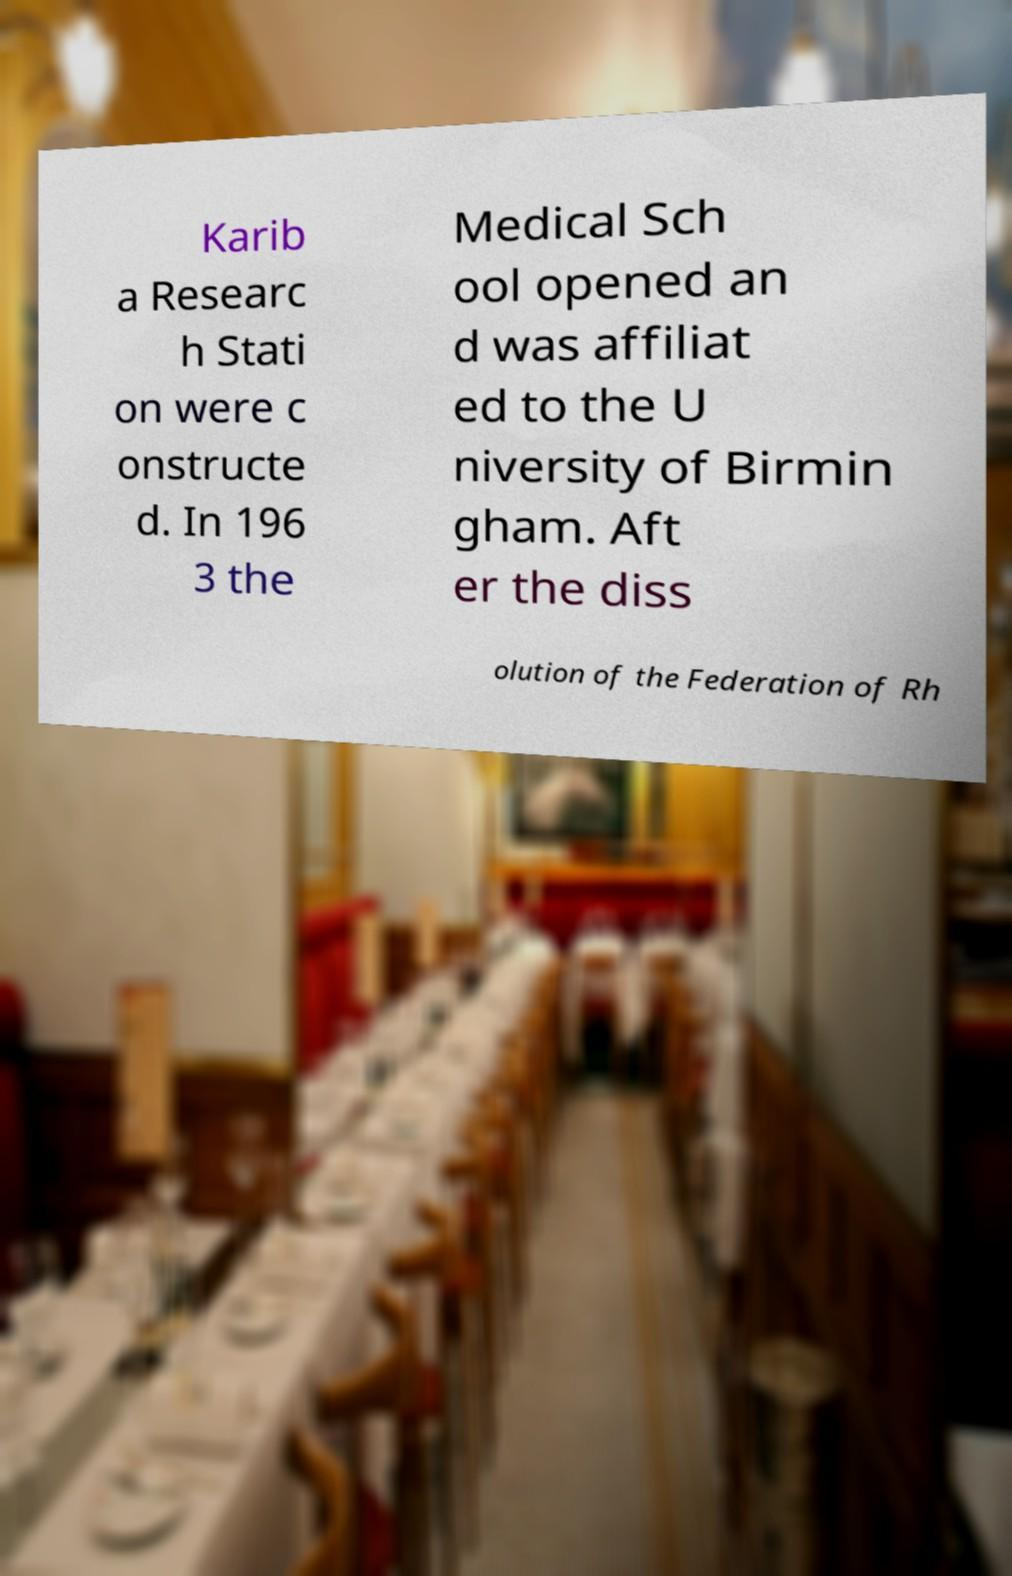Please read and relay the text visible in this image. What does it say? Karib a Researc h Stati on were c onstructe d. In 196 3 the Medical Sch ool opened an d was affiliat ed to the U niversity of Birmin gham. Aft er the diss olution of the Federation of Rh 